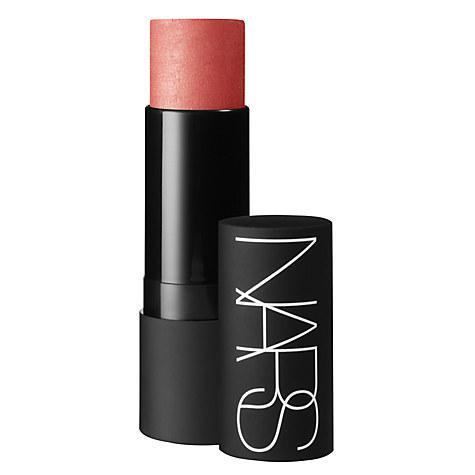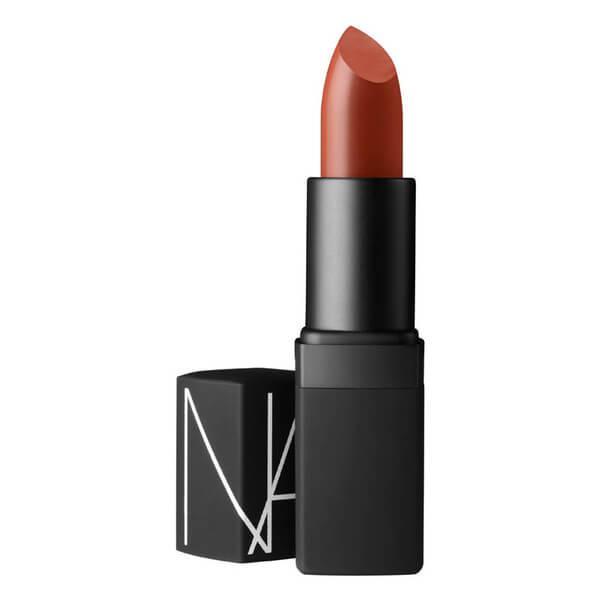The first image is the image on the left, the second image is the image on the right. Given the left and right images, does the statement "the left image has flat topped lipstick" hold true? Answer yes or no. Yes. 